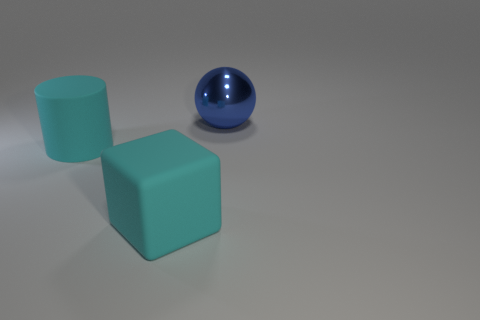The cyan cube has what size?
Keep it short and to the point. Large. What size is the cyan rubber object that is on the left side of the big rubber block?
Provide a succinct answer. Large. How many metal balls are behind the cyan rubber thing to the right of the big cyan rubber cylinder?
Your answer should be very brief. 1. How many blue things are either metallic things or small balls?
Your response must be concise. 1. Are there any other things that have the same color as the cube?
Make the answer very short. Yes. What color is the matte object that is behind the cyan rubber thing that is in front of the cyan rubber cylinder?
Your answer should be compact. Cyan. Are there fewer big blue objects that are behind the large blue object than cyan objects that are behind the large matte block?
Offer a very short reply. Yes. What material is the cylinder that is the same color as the matte block?
Make the answer very short. Rubber. How many objects are either objects in front of the blue object or large yellow balls?
Your answer should be very brief. 2. Do the blue metal sphere that is behind the matte cylinder and the cyan matte cylinder have the same size?
Keep it short and to the point. Yes. 